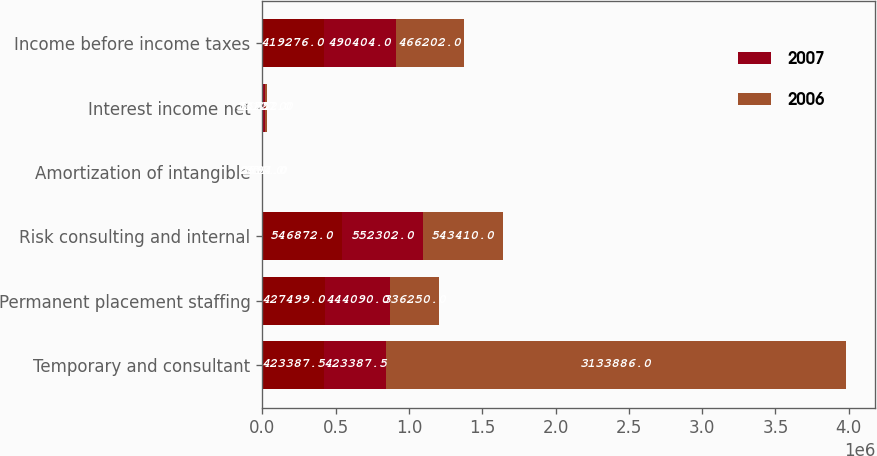Convert chart to OTSL. <chart><loc_0><loc_0><loc_500><loc_500><stacked_bar_chart><ecel><fcel>Temporary and consultant<fcel>Permanent placement staffing<fcel>Risk consulting and internal<fcel>Amortization of intangible<fcel>Interest income net<fcel>Income before income taxes<nl><fcel>nan<fcel>423388<fcel>427499<fcel>546872<fcel>2617<fcel>5161<fcel>419276<nl><fcel>2007<fcel>423388<fcel>444090<fcel>552302<fcel>2594<fcel>13127<fcel>490404<nl><fcel>2006<fcel>3.13389e+06<fcel>336250<fcel>543410<fcel>851<fcel>16752<fcel>466202<nl></chart> 